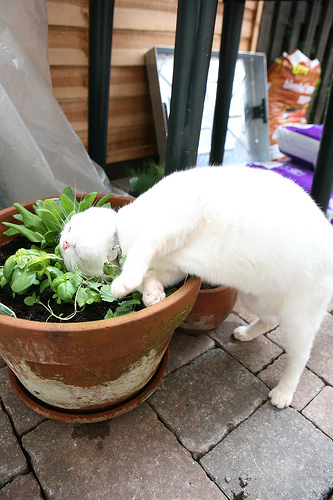Which kind of animal is on the sidewalk? The animal on the sidewalk is a cat. 